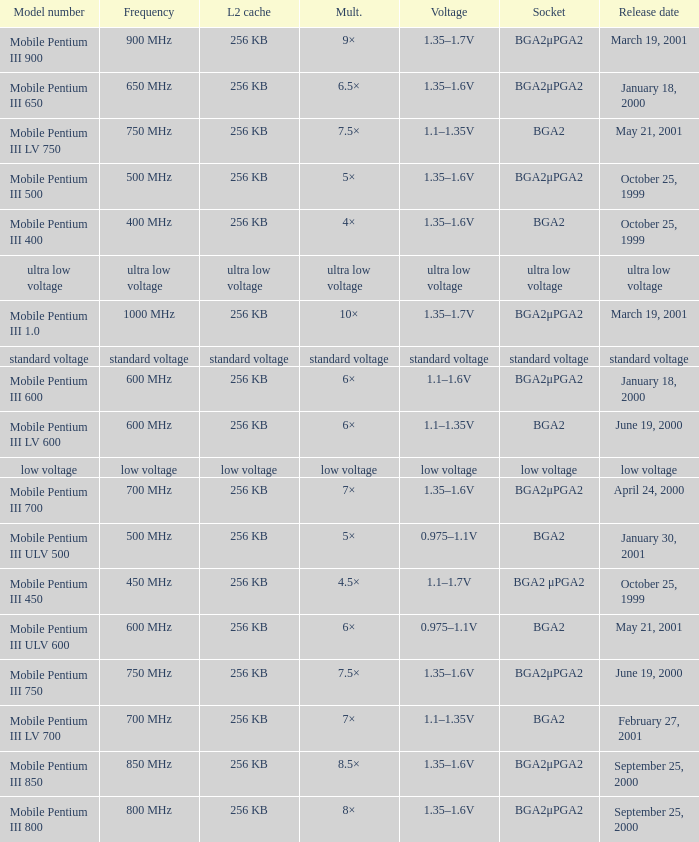Which model has a frequency of 750 mhz and a socket of bga2μpga2? Mobile Pentium III 750. 